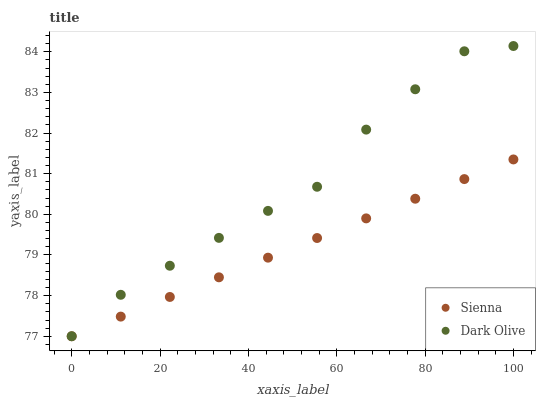Does Sienna have the minimum area under the curve?
Answer yes or no. Yes. Does Dark Olive have the maximum area under the curve?
Answer yes or no. Yes. Does Dark Olive have the minimum area under the curve?
Answer yes or no. No. Is Sienna the smoothest?
Answer yes or no. Yes. Is Dark Olive the roughest?
Answer yes or no. Yes. Is Dark Olive the smoothest?
Answer yes or no. No. Does Sienna have the lowest value?
Answer yes or no. Yes. Does Dark Olive have the highest value?
Answer yes or no. Yes. Does Sienna intersect Dark Olive?
Answer yes or no. Yes. Is Sienna less than Dark Olive?
Answer yes or no. No. Is Sienna greater than Dark Olive?
Answer yes or no. No. 